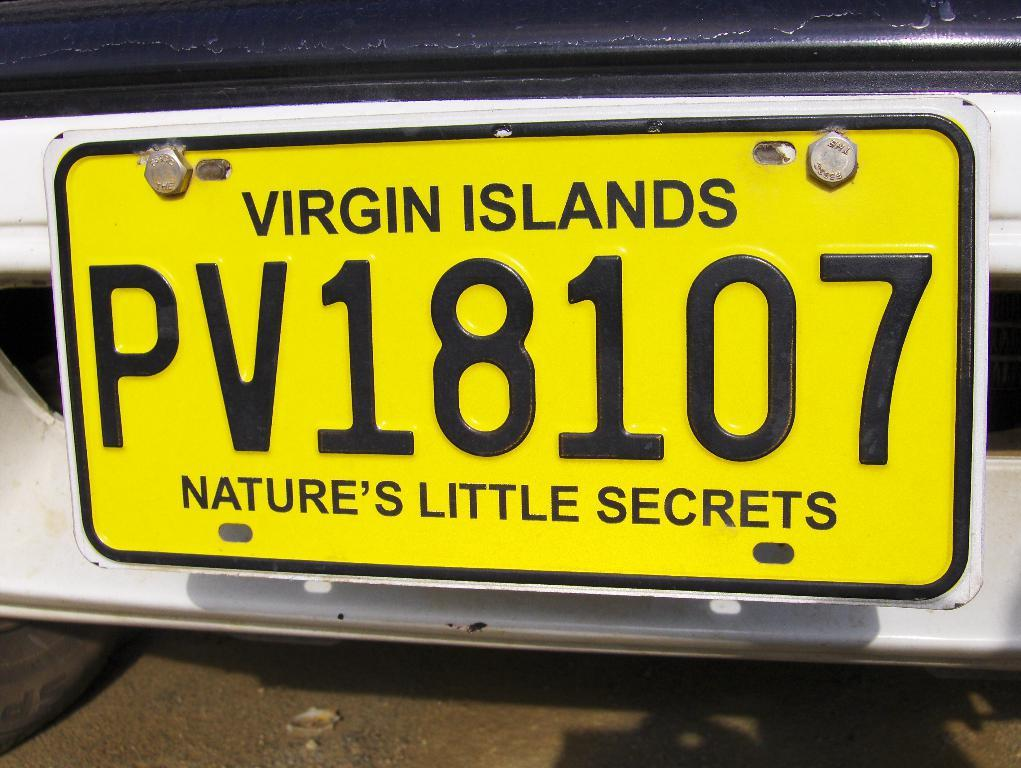Provide a one-sentence caption for the provided image. A yellow Virgin Islands license plate with PV18107 on it. 